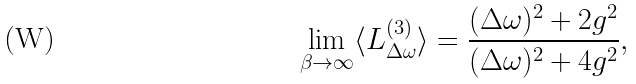Convert formula to latex. <formula><loc_0><loc_0><loc_500><loc_500>\lim _ { \beta \to \infty } \langle L _ { \Delta \omega } ^ { ( 3 ) } \rangle = \frac { ( \Delta \omega ) ^ { 2 } + 2 g ^ { 2 } } { ( \Delta \omega ) ^ { 2 } + 4 g ^ { 2 } } ,</formula> 